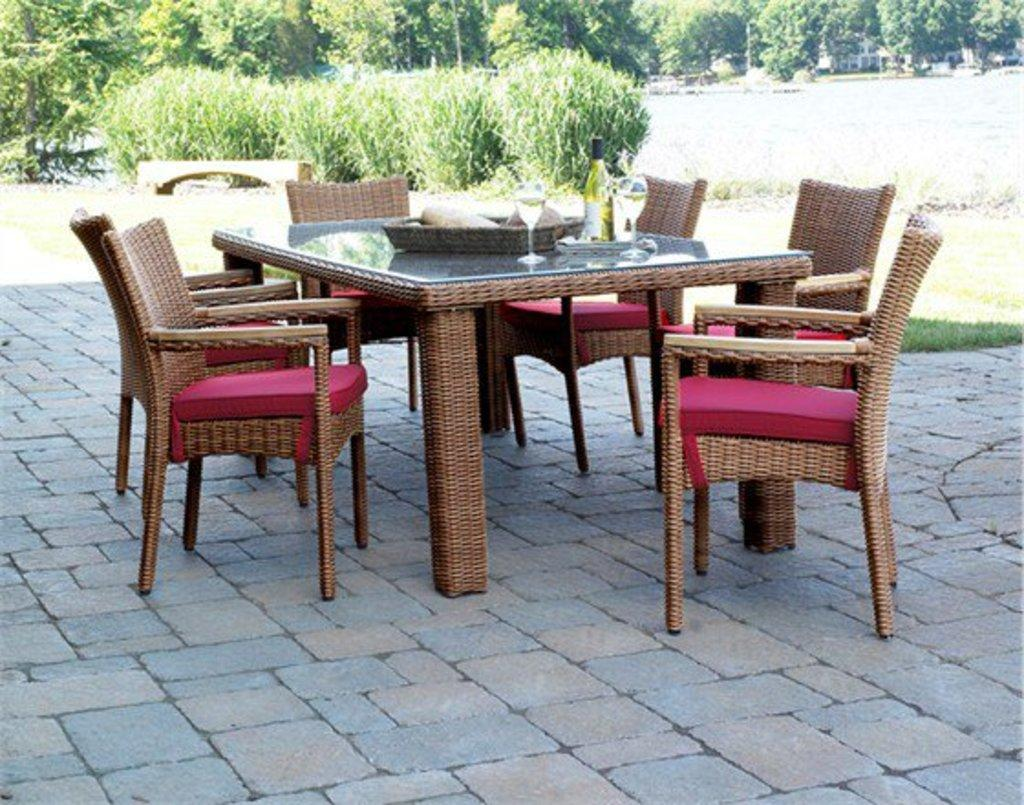What type of furniture is present in the image? There is a dining table in the image. What is placed on the dining table? There is a tray with a beverage bottle and glass tumblers on the dining table. Can you describe any other objects in the image? There is a woven basket in the image. What can be seen in the background of the image? There are bushes, trees, buildings, and grass in the background of the image. What type of stick is being used to stir the beverage in the glass tumbler? There is no stick visible in the image, and the beverage bottle is not open. --- 